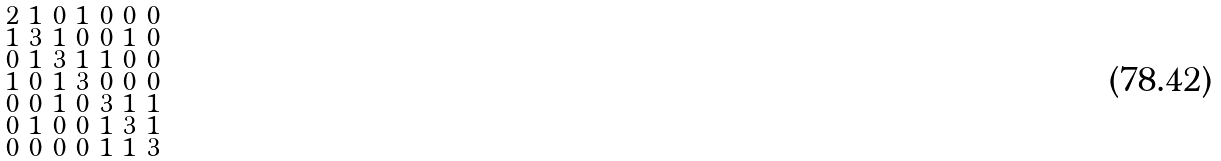Convert formula to latex. <formula><loc_0><loc_0><loc_500><loc_500>\begin{smallmatrix} 2 & 1 & 0 & 1 & 0 & 0 & 0 \\ 1 & 3 & 1 & 0 & 0 & 1 & 0 \\ 0 & 1 & 3 & 1 & 1 & 0 & 0 \\ 1 & 0 & 1 & 3 & 0 & 0 & 0 \\ 0 & 0 & 1 & 0 & 3 & 1 & 1 \\ 0 & 1 & 0 & 0 & 1 & 3 & 1 \\ 0 & 0 & 0 & 0 & 1 & 1 & 3 \end{smallmatrix}</formula> 